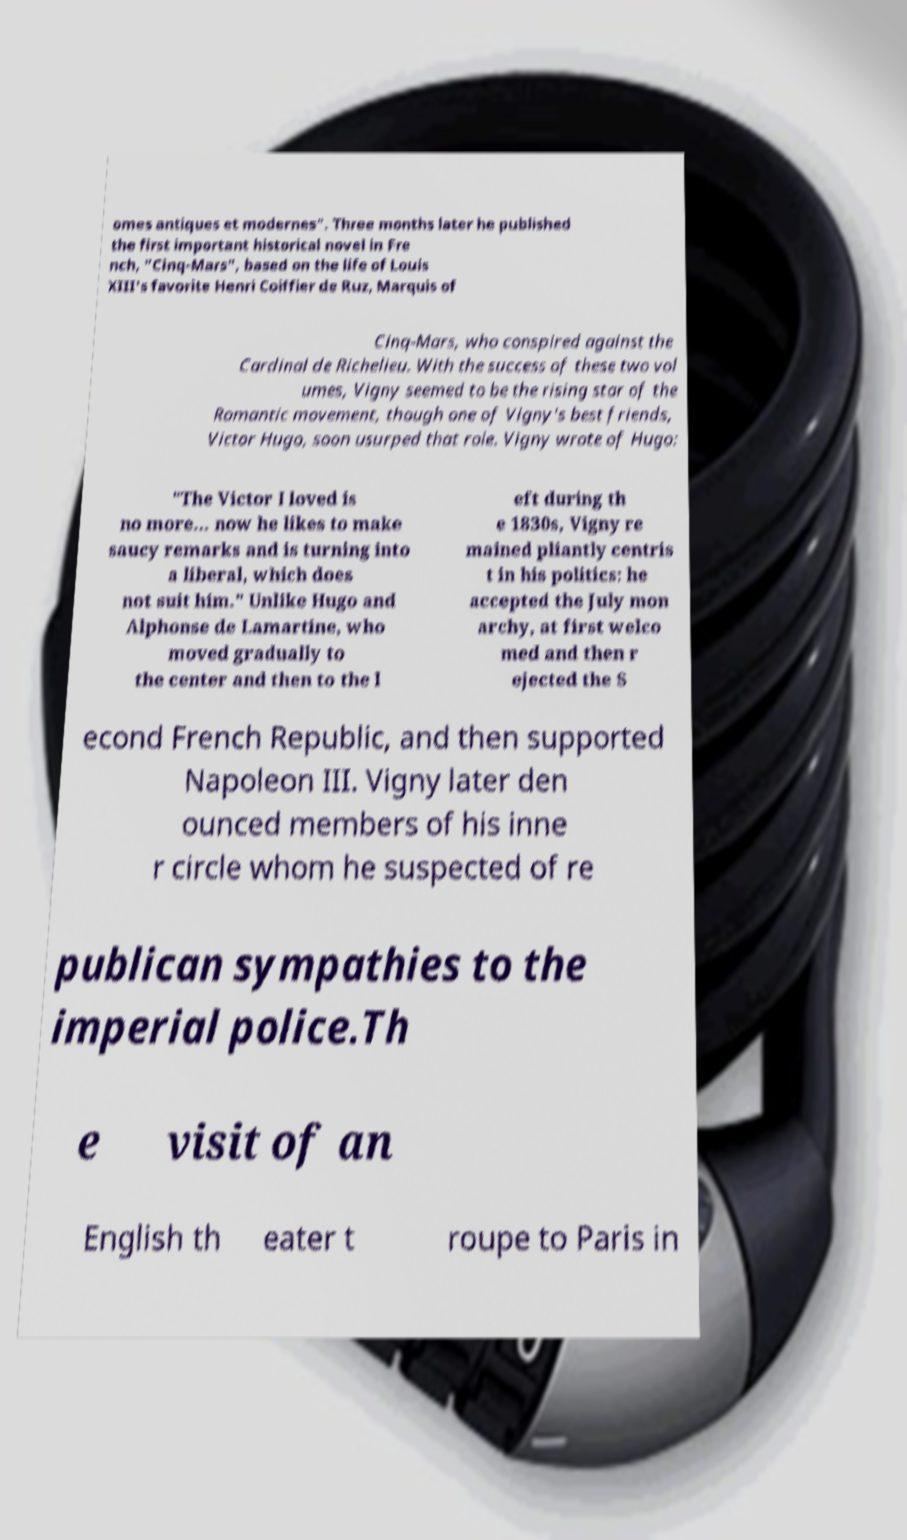What messages or text are displayed in this image? I need them in a readable, typed format. omes antiques et modernes". Three months later he published the first important historical novel in Fre nch, "Cinq-Mars", based on the life of Louis XIII's favorite Henri Coiffier de Ruz, Marquis of Cinq-Mars, who conspired against the Cardinal de Richelieu. With the success of these two vol umes, Vigny seemed to be the rising star of the Romantic movement, though one of Vigny's best friends, Victor Hugo, soon usurped that role. Vigny wrote of Hugo: "The Victor I loved is no more... now he likes to make saucy remarks and is turning into a liberal, which does not suit him." Unlike Hugo and Alphonse de Lamartine, who moved gradually to the center and then to the l eft during th e 1830s, Vigny re mained pliantly centris t in his politics: he accepted the July mon archy, at first welco med and then r ejected the S econd French Republic, and then supported Napoleon III. Vigny later den ounced members of his inne r circle whom he suspected of re publican sympathies to the imperial police.Th e visit of an English th eater t roupe to Paris in 